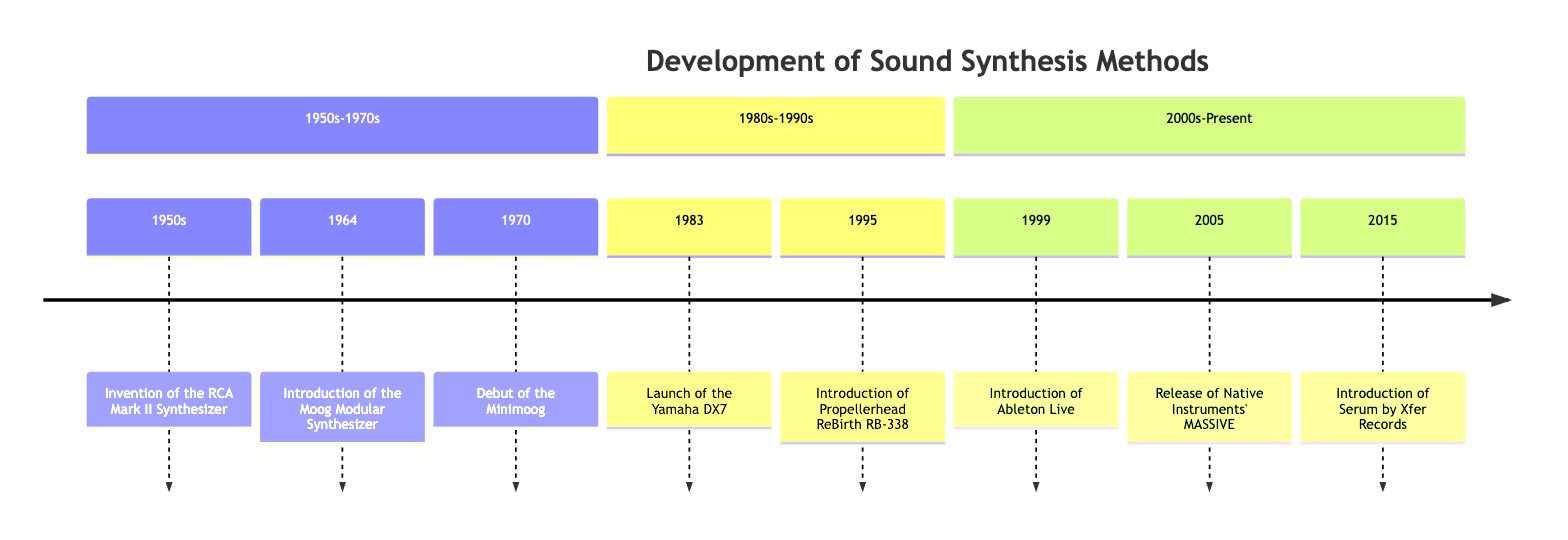What event marked the beginning of programmable electronic sound synthesizers? The diagram indicates that the Invention of the RCA Mark II Synthesizer in the 1950s was one of the first programmable electronic sound synthesizers.
Answer: Invention of the RCA Mark II Synthesizer Who introduced voltage-controlled oscillators and filters in 1964? The diagram shows that Robert Moog introduced the Moog Modular Synthesizer in 1964, which featured voltage-controlled oscillators and filters.
Answer: Robert Moog What year did the Minimoog debut? According to the timeline, the Minimoog debuted in the year 1970.
Answer: 1970 Which synthesizer launched in 1983 was the first commercially successful digital synthesizer? The timeline states that the Yamaha DX7, launched in 1983, was the first commercially successful digital synthesizer.
Answer: Yamaha DX7 What significant development in software synthesizers occurred in 1995? The diagram details that in 1995, the introduction of Propellerhead ReBirth RB-338 marked a significant development as one of the first software synthesizers.
Answer: Introduction of Propellerhead ReBirth RB-338 How many decades are represented in this timeline? The timeline spans from the 1950s to 2015, which includes multiple decades: the 1950s, 1960s, 1970s, 1980s, 1990s, 2000s, and the 2010s, totaling seven decades.
Answer: Seven decades What type of synthesis did the Yamaha DX7 utilize? The timeline mentions that the Yamaha DX7 utilized FM synthesis, which was a significant innovation in sound design.
Answer: FM synthesis What was a key feature introduced by Ableton Live in 1999? The diagram indicates that Ableton Live revolutionized music production with its unique approach to sequencing and clip-based arrangement, emphasizing real-time performance as a key feature.
Answer: Clip-based arrangement What major synthesis method is associated with Native Instruments' MASSIVE introduced in 2005? The timeline indicates that Native Instruments' MASSIVE, released in 2005, is known for its wavetable synthesis, which has become a staple in modern electronic music.
Answer: Wavetable synthesis 